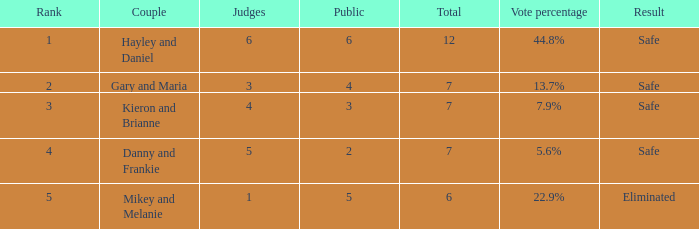How many judges were there for the eliminated couple?  1.0. 